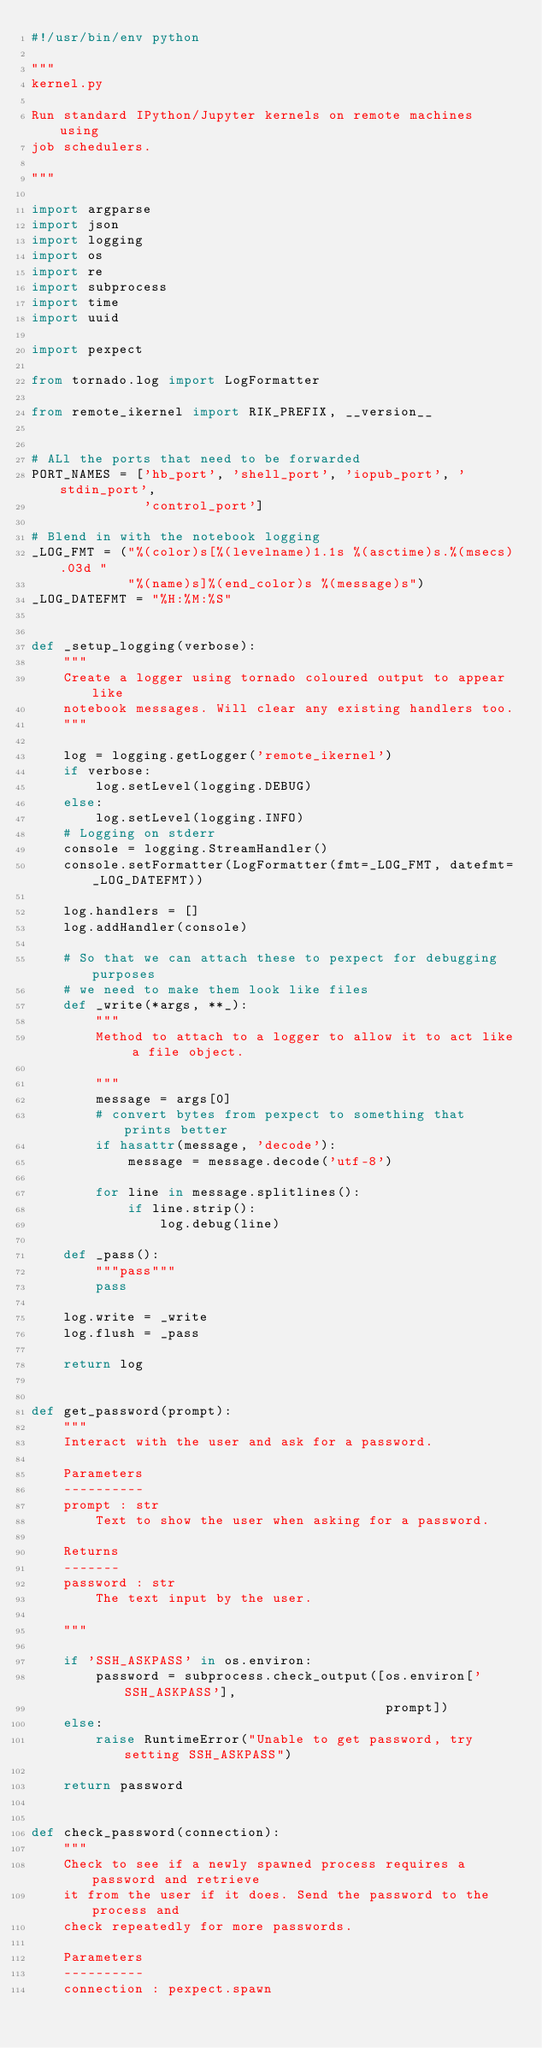<code> <loc_0><loc_0><loc_500><loc_500><_Python_>#!/usr/bin/env python

"""
kernel.py

Run standard IPython/Jupyter kernels on remote machines using
job schedulers.

"""

import argparse
import json
import logging
import os
import re
import subprocess
import time
import uuid

import pexpect

from tornado.log import LogFormatter

from remote_ikernel import RIK_PREFIX, __version__


# ALl the ports that need to be forwarded
PORT_NAMES = ['hb_port', 'shell_port', 'iopub_port', 'stdin_port',
              'control_port']

# Blend in with the notebook logging
_LOG_FMT = ("%(color)s[%(levelname)1.1s %(asctime)s.%(msecs).03d "
            "%(name)s]%(end_color)s %(message)s")
_LOG_DATEFMT = "%H:%M:%S"


def _setup_logging(verbose):
    """
    Create a logger using tornado coloured output to appear like
    notebook messages. Will clear any existing handlers too.
    """

    log = logging.getLogger('remote_ikernel')
    if verbose:
        log.setLevel(logging.DEBUG)
    else:
        log.setLevel(logging.INFO)
    # Logging on stderr
    console = logging.StreamHandler()
    console.setFormatter(LogFormatter(fmt=_LOG_FMT, datefmt=_LOG_DATEFMT))

    log.handlers = []
    log.addHandler(console)

    # So that we can attach these to pexpect for debugging purposes
    # we need to make them look like files
    def _write(*args, **_):
        """
        Method to attach to a logger to allow it to act like a file object.

        """
        message = args[0]
        # convert bytes from pexpect to something that prints better
        if hasattr(message, 'decode'):
            message = message.decode('utf-8')

        for line in message.splitlines():
            if line.strip():
                log.debug(line)

    def _pass():
        """pass"""
        pass

    log.write = _write
    log.flush = _pass

    return log


def get_password(prompt):
    """
    Interact with the user and ask for a password.

    Parameters
    ----------
    prompt : str
        Text to show the user when asking for a password.

    Returns
    -------
    password : str
        The text input by the user.

    """

    if 'SSH_ASKPASS' in os.environ:
        password = subprocess.check_output([os.environ['SSH_ASKPASS'],
                                            prompt])
    else:
        raise RuntimeError("Unable to get password, try setting SSH_ASKPASS")

    return password


def check_password(connection):
    """
    Check to see if a newly spawned process requires a password and retrieve
    it from the user if it does. Send the password to the process and
    check repeatedly for more passwords.

    Parameters
    ----------
    connection : pexpect.spawn</code> 